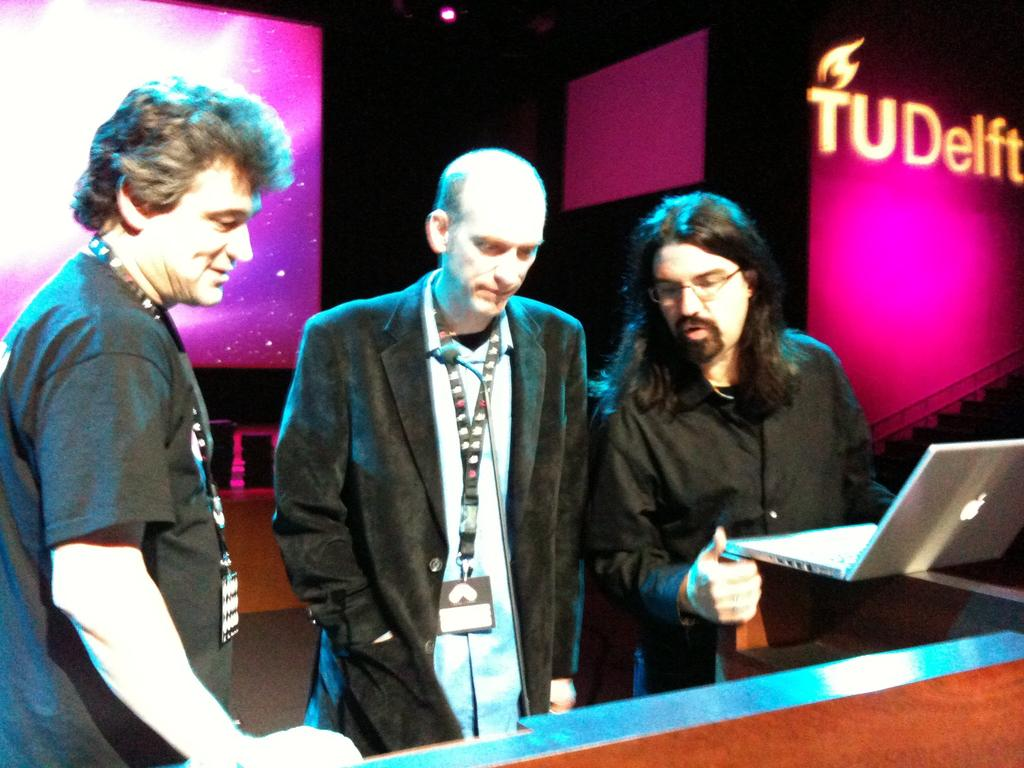How many people are in the image? There are three persons standing in the image. What is one of the persons holding? One person is standing and holding a laptop. What can be seen on the wall in the background? There is text on a wall in the background. What is the source of light visible at the top of the image? There is a light visible at the top of the image. What direction are the ants moving in the image? There are no ants present in the image. What type of scale is being used by the person holding the laptop? There is no scale visible in the image, and the person holding the laptop is not using any scale. 